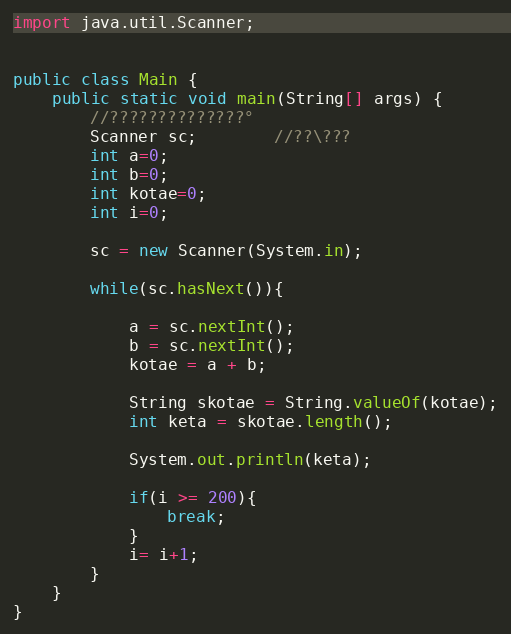Convert code to text. <code><loc_0><loc_0><loc_500><loc_500><_Java_>import java.util.Scanner;


public class Main {
	public static void main(String[] args) {
		//??????????????°
		Scanner sc;		//??\???
		int a=0;
		int b=0;
		int kotae=0;
		int i=0;

		sc = new Scanner(System.in);

		while(sc.hasNext()){

			a = sc.nextInt();
			b = sc.nextInt();
			kotae = a + b;

			String skotae = String.valueOf(kotae);
			int keta = skotae.length();

			System.out.println(keta);

			if(i >= 200){
				break;
			}
			i= i+1;
		}
	}
}</code> 